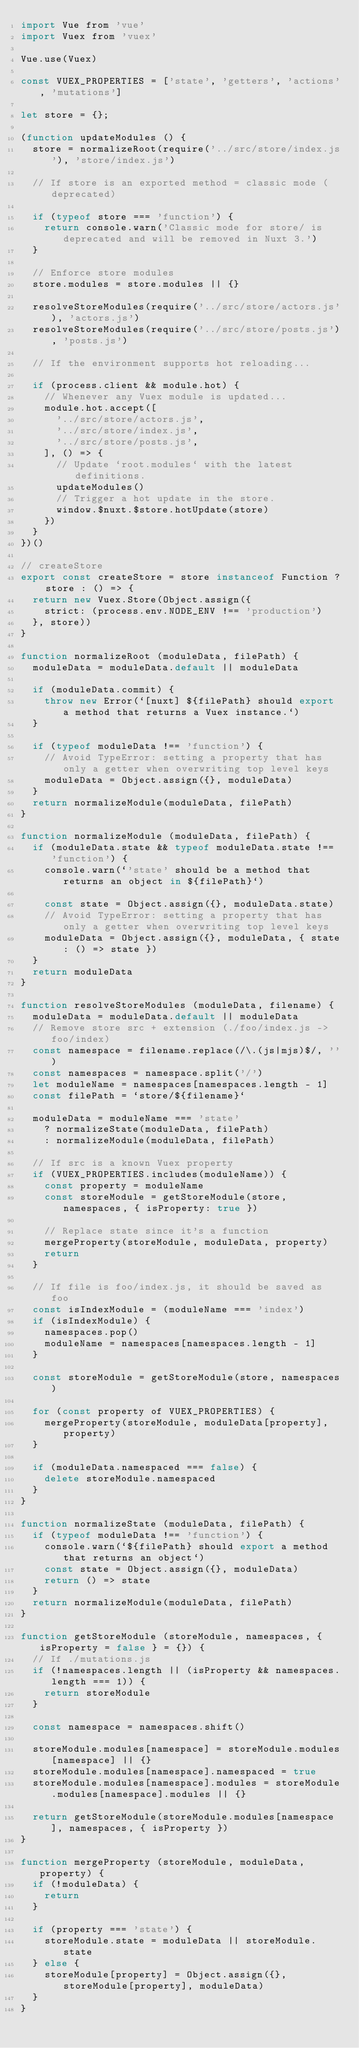Convert code to text. <code><loc_0><loc_0><loc_500><loc_500><_JavaScript_>import Vue from 'vue'
import Vuex from 'vuex'

Vue.use(Vuex)

const VUEX_PROPERTIES = ['state', 'getters', 'actions', 'mutations']

let store = {};

(function updateModules () {
  store = normalizeRoot(require('../src/store/index.js'), 'store/index.js')

  // If store is an exported method = classic mode (deprecated)

  if (typeof store === 'function') {
    return console.warn('Classic mode for store/ is deprecated and will be removed in Nuxt 3.')
  }

  // Enforce store modules
  store.modules = store.modules || {}

  resolveStoreModules(require('../src/store/actors.js'), 'actors.js')
  resolveStoreModules(require('../src/store/posts.js'), 'posts.js')

  // If the environment supports hot reloading...

  if (process.client && module.hot) {
    // Whenever any Vuex module is updated...
    module.hot.accept([
      '../src/store/actors.js',
      '../src/store/index.js',
      '../src/store/posts.js',
    ], () => {
      // Update `root.modules` with the latest definitions.
      updateModules()
      // Trigger a hot update in the store.
      window.$nuxt.$store.hotUpdate(store)
    })
  }
})()

// createStore
export const createStore = store instanceof Function ? store : () => {
  return new Vuex.Store(Object.assign({
    strict: (process.env.NODE_ENV !== 'production')
  }, store))
}

function normalizeRoot (moduleData, filePath) {
  moduleData = moduleData.default || moduleData

  if (moduleData.commit) {
    throw new Error(`[nuxt] ${filePath} should export a method that returns a Vuex instance.`)
  }

  if (typeof moduleData !== 'function') {
    // Avoid TypeError: setting a property that has only a getter when overwriting top level keys
    moduleData = Object.assign({}, moduleData)
  }
  return normalizeModule(moduleData, filePath)
}

function normalizeModule (moduleData, filePath) {
  if (moduleData.state && typeof moduleData.state !== 'function') {
    console.warn(`'state' should be a method that returns an object in ${filePath}`)

    const state = Object.assign({}, moduleData.state)
    // Avoid TypeError: setting a property that has only a getter when overwriting top level keys
    moduleData = Object.assign({}, moduleData, { state: () => state })
  }
  return moduleData
}

function resolveStoreModules (moduleData, filename) {
  moduleData = moduleData.default || moduleData
  // Remove store src + extension (./foo/index.js -> foo/index)
  const namespace = filename.replace(/\.(js|mjs)$/, '')
  const namespaces = namespace.split('/')
  let moduleName = namespaces[namespaces.length - 1]
  const filePath = `store/${filename}`

  moduleData = moduleName === 'state'
    ? normalizeState(moduleData, filePath)
    : normalizeModule(moduleData, filePath)

  // If src is a known Vuex property
  if (VUEX_PROPERTIES.includes(moduleName)) {
    const property = moduleName
    const storeModule = getStoreModule(store, namespaces, { isProperty: true })

    // Replace state since it's a function
    mergeProperty(storeModule, moduleData, property)
    return
  }

  // If file is foo/index.js, it should be saved as foo
  const isIndexModule = (moduleName === 'index')
  if (isIndexModule) {
    namespaces.pop()
    moduleName = namespaces[namespaces.length - 1]
  }

  const storeModule = getStoreModule(store, namespaces)

  for (const property of VUEX_PROPERTIES) {
    mergeProperty(storeModule, moduleData[property], property)
  }

  if (moduleData.namespaced === false) {
    delete storeModule.namespaced
  }
}

function normalizeState (moduleData, filePath) {
  if (typeof moduleData !== 'function') {
    console.warn(`${filePath} should export a method that returns an object`)
    const state = Object.assign({}, moduleData)
    return () => state
  }
  return normalizeModule(moduleData, filePath)
}

function getStoreModule (storeModule, namespaces, { isProperty = false } = {}) {
  // If ./mutations.js
  if (!namespaces.length || (isProperty && namespaces.length === 1)) {
    return storeModule
  }

  const namespace = namespaces.shift()

  storeModule.modules[namespace] = storeModule.modules[namespace] || {}
  storeModule.modules[namespace].namespaced = true
  storeModule.modules[namespace].modules = storeModule.modules[namespace].modules || {}

  return getStoreModule(storeModule.modules[namespace], namespaces, { isProperty })
}

function mergeProperty (storeModule, moduleData, property) {
  if (!moduleData) {
    return
  }

  if (property === 'state') {
    storeModule.state = moduleData || storeModule.state
  } else {
    storeModule[property] = Object.assign({}, storeModule[property], moduleData)
  }
}
</code> 